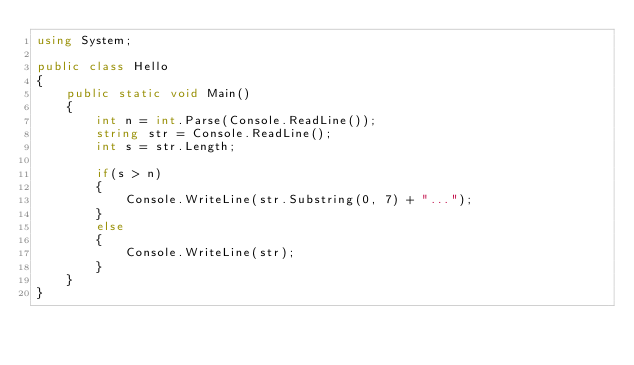<code> <loc_0><loc_0><loc_500><loc_500><_C#_>using System;

public class Hello
{
    public static void Main()
    {
        int n = int.Parse(Console.ReadLine());
        string str = Console.ReadLine();
        int s = str.Length;

        if(s > n)
        {
            Console.WriteLine(str.Substring(0, 7) + "...");
        }
        else
        {
            Console.WriteLine(str);
        }
    }
}</code> 